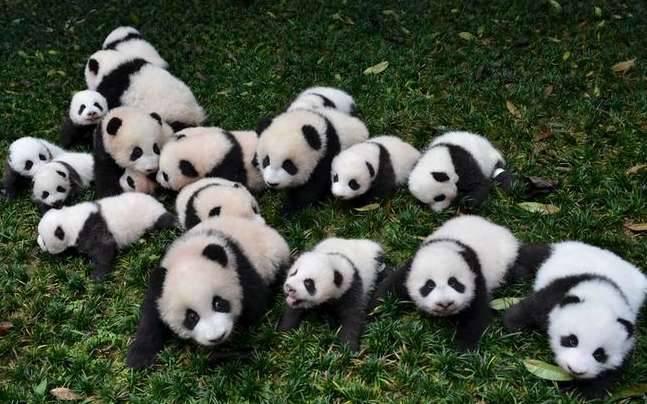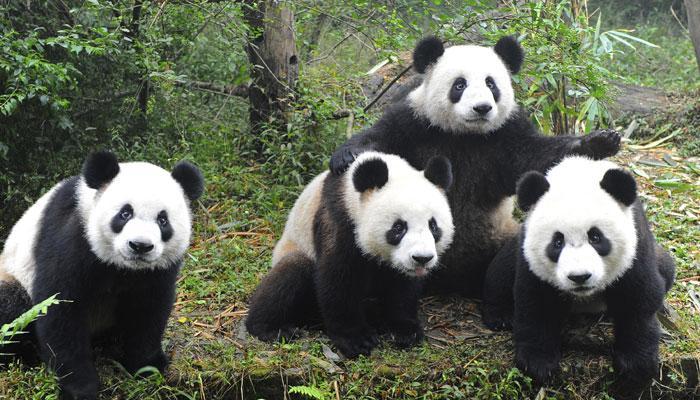The first image is the image on the left, the second image is the image on the right. For the images displayed, is the sentence "The image to the left features exactly four pandas." factually correct? Answer yes or no. No. The first image is the image on the left, the second image is the image on the right. Examine the images to the left and right. Is the description "An image with exactly four pandas includes one with its front paws outspread, reaching toward the panda on either side of it." accurate? Answer yes or no. Yes. 